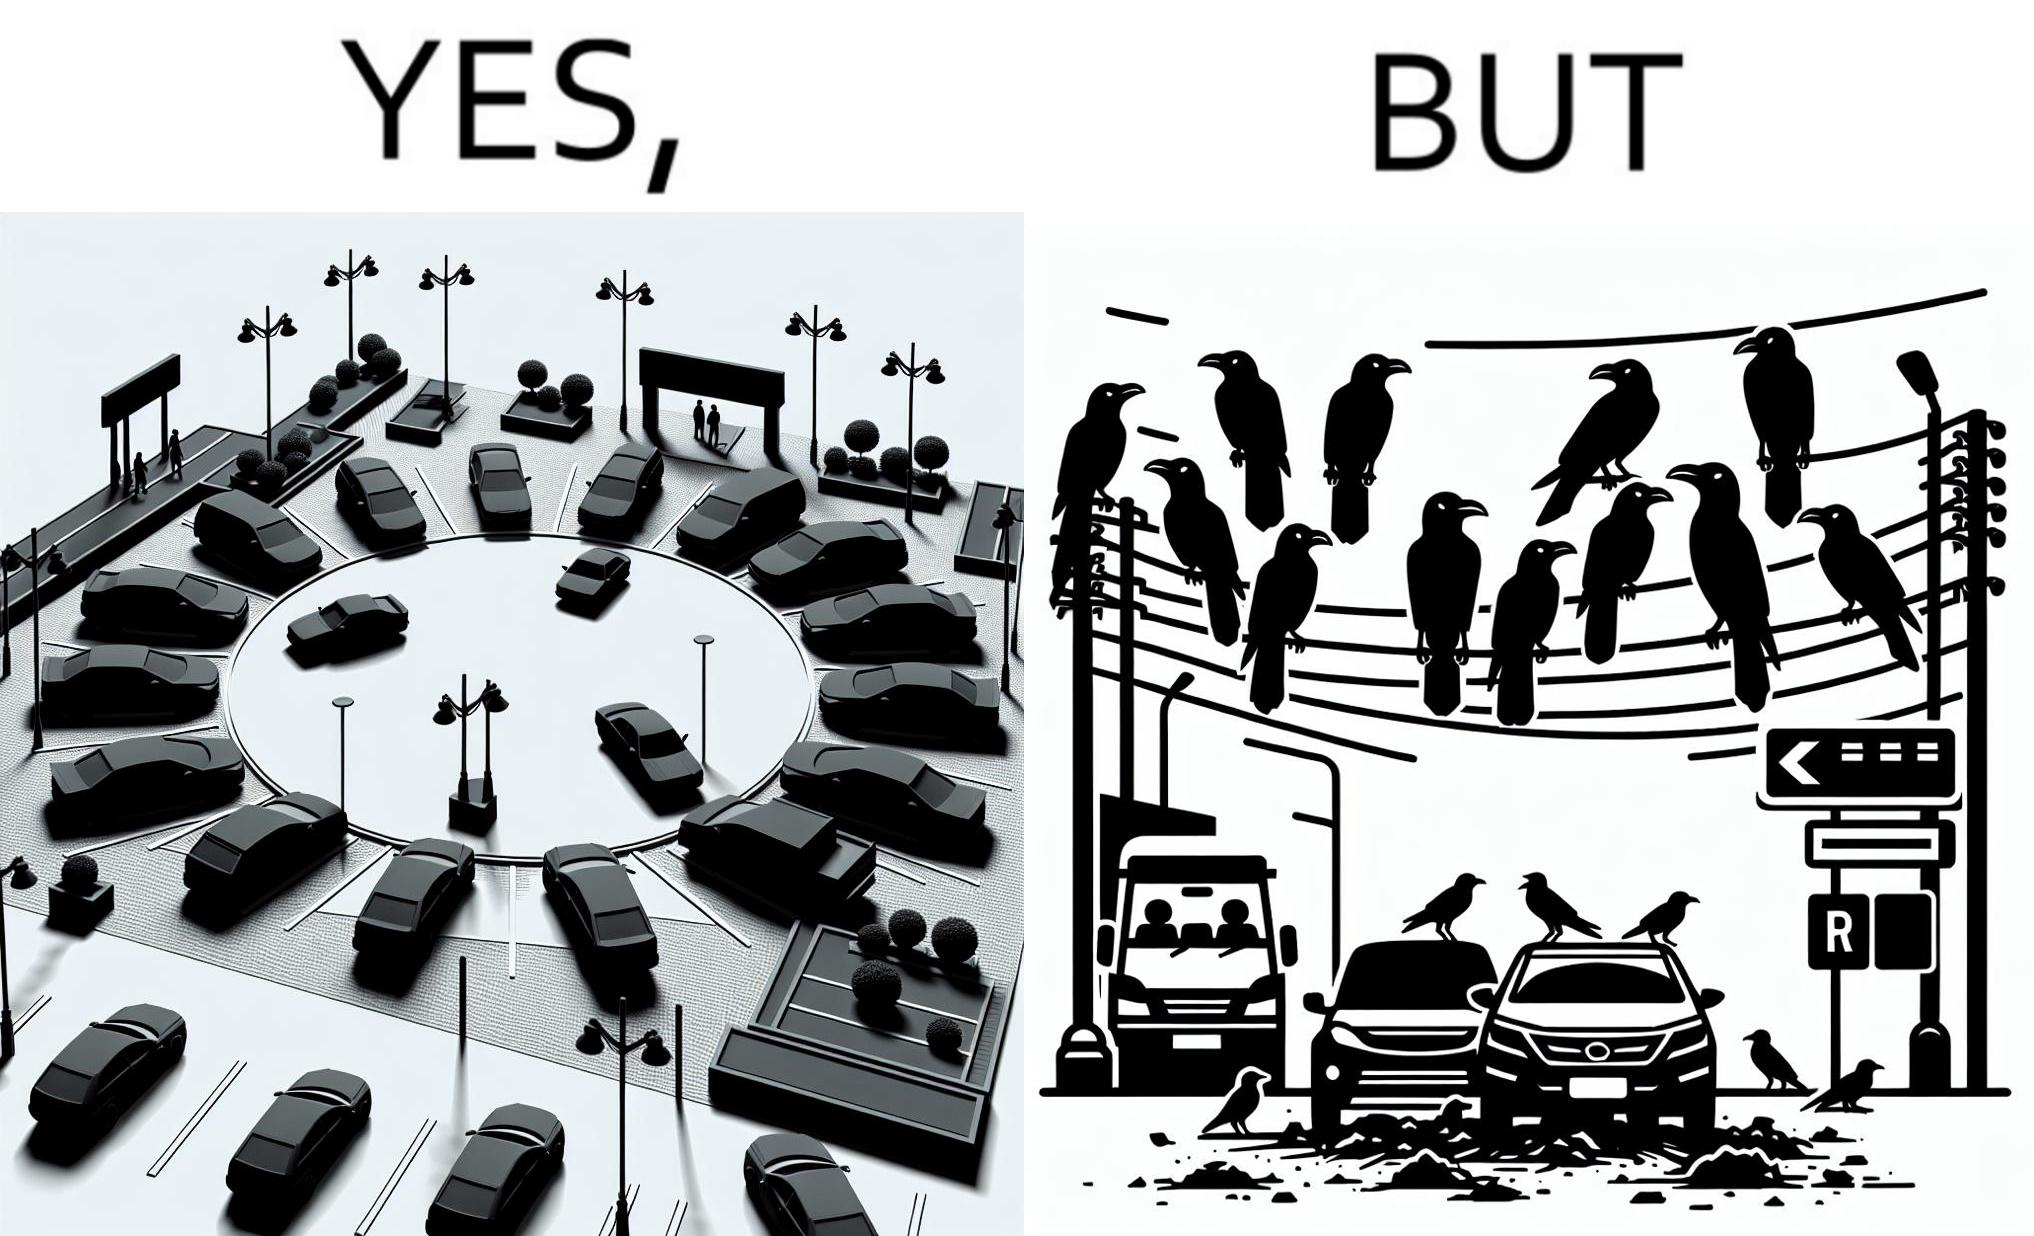Does this image contain satire or humor? Yes, this image is satirical. 